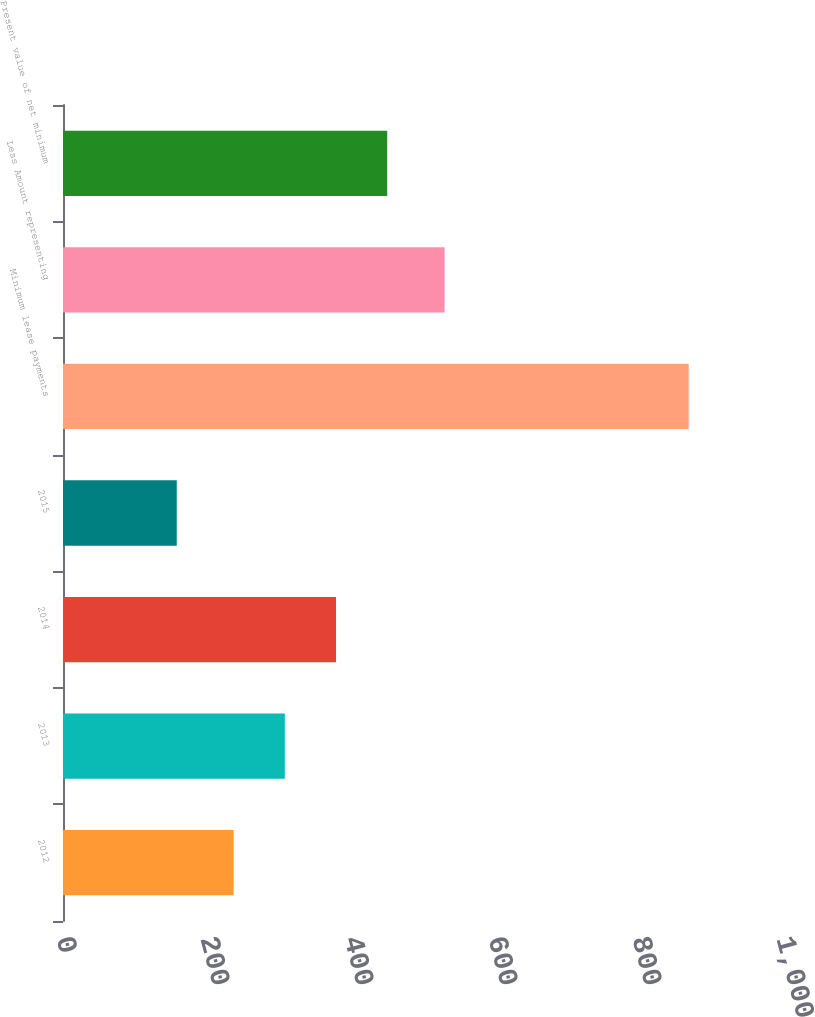Convert chart to OTSL. <chart><loc_0><loc_0><loc_500><loc_500><bar_chart><fcel>2012<fcel>2013<fcel>2014<fcel>2015<fcel>Minimum lease payments<fcel>Less Amount representing<fcel>Present value of net minimum<nl><fcel>237<fcel>308.1<fcel>379.2<fcel>158<fcel>869<fcel>530<fcel>450.3<nl></chart> 